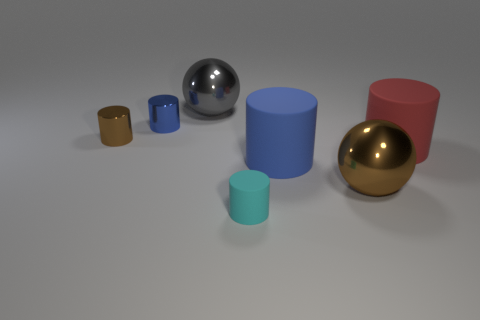There is a cyan object that is the same shape as the red object; what is it made of?
Keep it short and to the point. Rubber. Are there more large spheres than shiny things?
Ensure brevity in your answer.  No. There is a small cylinder that is both to the right of the tiny brown metal cylinder and behind the big brown thing; what is its material?
Your answer should be compact. Metal. What number of other objects are there of the same material as the big blue thing?
Keep it short and to the point. 2. What number of large things have the same color as the tiny matte thing?
Ensure brevity in your answer.  0. What is the size of the blue thing that is to the right of the large sphere that is behind the big metallic sphere that is to the right of the small cyan rubber object?
Keep it short and to the point. Large. How many rubber things are either gray objects or tiny blue objects?
Offer a terse response. 0. Do the big brown metallic thing and the big shiny thing that is behind the red matte cylinder have the same shape?
Keep it short and to the point. Yes. Is the number of big metal balls behind the small brown shiny object greater than the number of blue shiny objects to the left of the tiny blue thing?
Make the answer very short. Yes. Is there anything else that has the same color as the tiny rubber cylinder?
Give a very brief answer. No. 